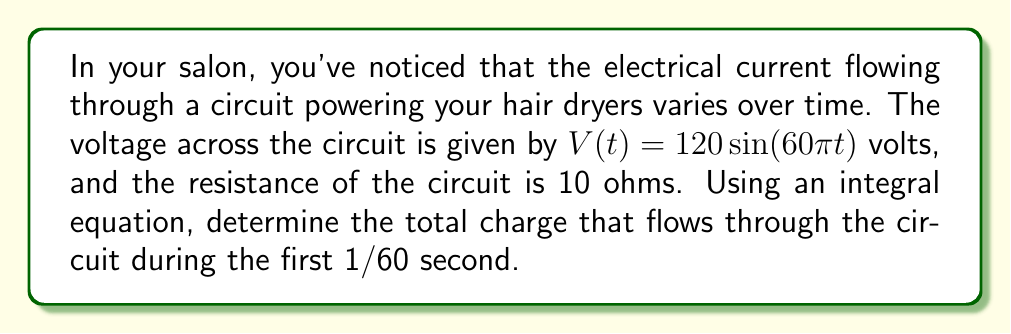What is the answer to this math problem? To solve this problem, we'll follow these steps:

1) First, recall Ohm's Law: $V = IR$, where $V$ is voltage, $I$ is current, and $R$ is resistance.

2) Rearrange this to express current in terms of voltage and resistance:

   $I = \frac{V}{R}$

3) In this case, $V$ is a function of time, so we have:

   $I(t) = \frac{V(t)}{R} = \frac{120\sin(60\pi t)}{10} = 12\sin(60\pi t)$ amperes

4) The charge $Q$ that flows through a circuit is given by the integral of current over time:

   $Q = \int I(t) dt$

5) Substituting our expression for $I(t)$:

   $Q = \int_0^{1/60} 12\sin(60\pi t) dt$

6) To solve this integral, we can use the antiderivative of sine:

   $\int \sin(ax) dx = -\frac{1}{a}\cos(ax) + C$

7) Applying this to our integral:

   $Q = 12 \cdot \left[-\frac{1}{60\pi}\cos(60\pi t)\right]_0^{1/60}$

8) Evaluating the definite integral:

   $Q = 12 \cdot \left[-\frac{1}{60\pi}\cos(60\pi \cdot \frac{1}{60}) + \frac{1}{60\pi}\cos(60\pi \cdot 0)\right]$
   
   $Q = 12 \cdot \left[-\frac{1}{60\pi}\cos(\pi) + \frac{1}{60\pi}\cos(0)\right]$
   
   $Q = 12 \cdot \left[-\frac{1}{60\pi}(-1) + \frac{1}{60\pi}(1)\right]$
   
   $Q = 12 \cdot \frac{2}{60\pi} = \frac{4}{10\pi}$ coulombs
Answer: $\frac{4}{10\pi}$ coulombs 